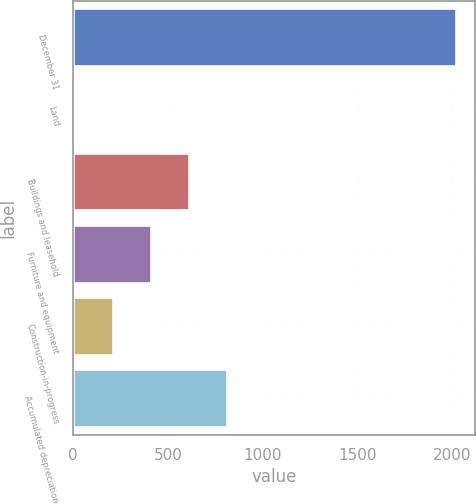Convert chart. <chart><loc_0><loc_0><loc_500><loc_500><bar_chart><fcel>December 31<fcel>Land<fcel>Buildings and leasehold<fcel>Furniture and equipment<fcel>Construction-in-progress<fcel>Accumulated depreciation<nl><fcel>2017<fcel>12<fcel>613.5<fcel>413<fcel>212.5<fcel>814<nl></chart> 